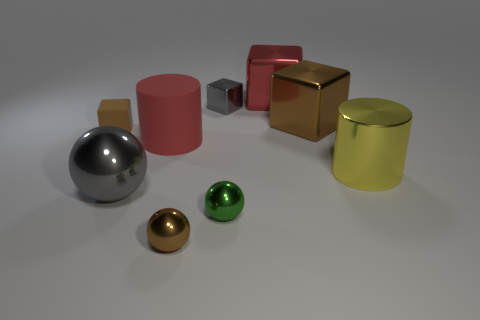Subtract 1 cubes. How many cubes are left? 3 Add 1 brown balls. How many objects exist? 10 Subtract all cylinders. How many objects are left? 7 Subtract 0 green blocks. How many objects are left? 9 Subtract all brown metal objects. Subtract all matte cylinders. How many objects are left? 6 Add 7 large cubes. How many large cubes are left? 9 Add 3 tiny rubber cylinders. How many tiny rubber cylinders exist? 3 